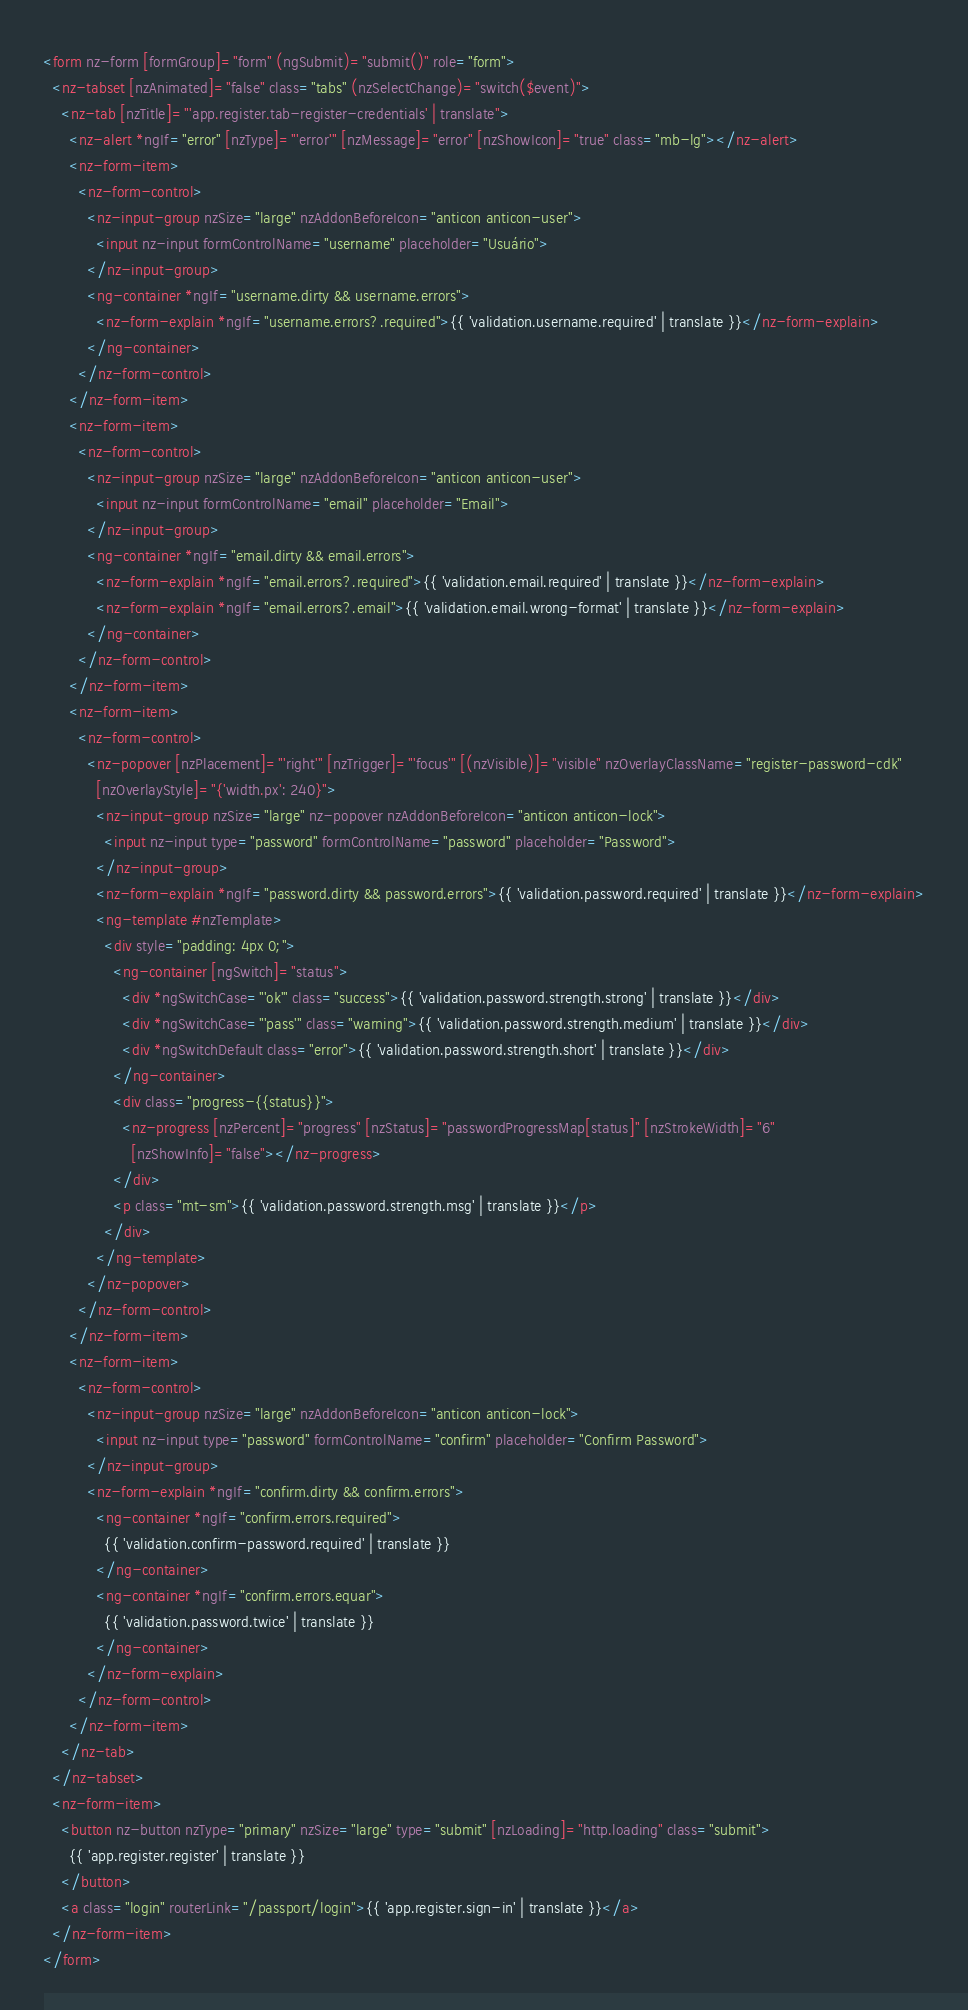<code> <loc_0><loc_0><loc_500><loc_500><_HTML_><form nz-form [formGroup]="form" (ngSubmit)="submit()" role="form">
  <nz-tabset [nzAnimated]="false" class="tabs" (nzSelectChange)="switch($event)">
    <nz-tab [nzTitle]="'app.register.tab-register-credentials' | translate">
      <nz-alert *ngIf="error" [nzType]="'error'" [nzMessage]="error" [nzShowIcon]="true" class="mb-lg"></nz-alert>
      <nz-form-item>
        <nz-form-control>
          <nz-input-group nzSize="large" nzAddonBeforeIcon="anticon anticon-user">
            <input nz-input formControlName="username" placeholder="Usuário">
          </nz-input-group>
          <ng-container *ngIf="username.dirty && username.errors">
            <nz-form-explain *ngIf="username.errors?.required">{{ 'validation.username.required' | translate }}</nz-form-explain>
          </ng-container>
        </nz-form-control>
      </nz-form-item>
      <nz-form-item>
        <nz-form-control>
          <nz-input-group nzSize="large" nzAddonBeforeIcon="anticon anticon-user">
            <input nz-input formControlName="email" placeholder="Email">
          </nz-input-group>
          <ng-container *ngIf="email.dirty && email.errors">
            <nz-form-explain *ngIf="email.errors?.required">{{ 'validation.email.required' | translate }}</nz-form-explain>
            <nz-form-explain *ngIf="email.errors?.email">{{ 'validation.email.wrong-format' | translate }}</nz-form-explain>
          </ng-container>
        </nz-form-control>
      </nz-form-item>
      <nz-form-item>
        <nz-form-control>
          <nz-popover [nzPlacement]="'right'" [nzTrigger]="'focus'" [(nzVisible)]="visible" nzOverlayClassName="register-password-cdk"
            [nzOverlayStyle]="{'width.px': 240}">
            <nz-input-group nzSize="large" nz-popover nzAddonBeforeIcon="anticon anticon-lock">
              <input nz-input type="password" formControlName="password" placeholder="Password">
            </nz-input-group>
            <nz-form-explain *ngIf="password.dirty && password.errors">{{ 'validation.password.required' | translate }}</nz-form-explain>
            <ng-template #nzTemplate>
              <div style="padding: 4px 0;">
                <ng-container [ngSwitch]="status">
                  <div *ngSwitchCase="'ok'" class="success">{{ 'validation.password.strength.strong' | translate }}</div>
                  <div *ngSwitchCase="'pass'" class="warning">{{ 'validation.password.strength.medium' | translate }}</div>
                  <div *ngSwitchDefault class="error">{{ 'validation.password.strength.short' | translate }}</div>
                </ng-container>
                <div class="progress-{{status}}">
                  <nz-progress [nzPercent]="progress" [nzStatus]="passwordProgressMap[status]" [nzStrokeWidth]="6"
                    [nzShowInfo]="false"></nz-progress>
                </div>
                <p class="mt-sm">{{ 'validation.password.strength.msg' | translate }}</p>
              </div>
            </ng-template>
          </nz-popover>
        </nz-form-control>
      </nz-form-item>
      <nz-form-item>
        <nz-form-control>
          <nz-input-group nzSize="large" nzAddonBeforeIcon="anticon anticon-lock">
            <input nz-input type="password" formControlName="confirm" placeholder="Confirm Password">
          </nz-input-group>
          <nz-form-explain *ngIf="confirm.dirty && confirm.errors">
            <ng-container *ngIf="confirm.errors.required">
              {{ 'validation.confirm-password.required' | translate }}
            </ng-container>
            <ng-container *ngIf="confirm.errors.equar">
              {{ 'validation.password.twice' | translate }}
            </ng-container>
          </nz-form-explain>
        </nz-form-control>
      </nz-form-item>
    </nz-tab>
  </nz-tabset>
  <nz-form-item>
    <button nz-button nzType="primary" nzSize="large" type="submit" [nzLoading]="http.loading" class="submit">
      {{ 'app.register.register' | translate }}
    </button>
    <a class="login" routerLink="/passport/login">{{ 'app.register.sign-in' | translate }}</a>
  </nz-form-item>
</form></code> 